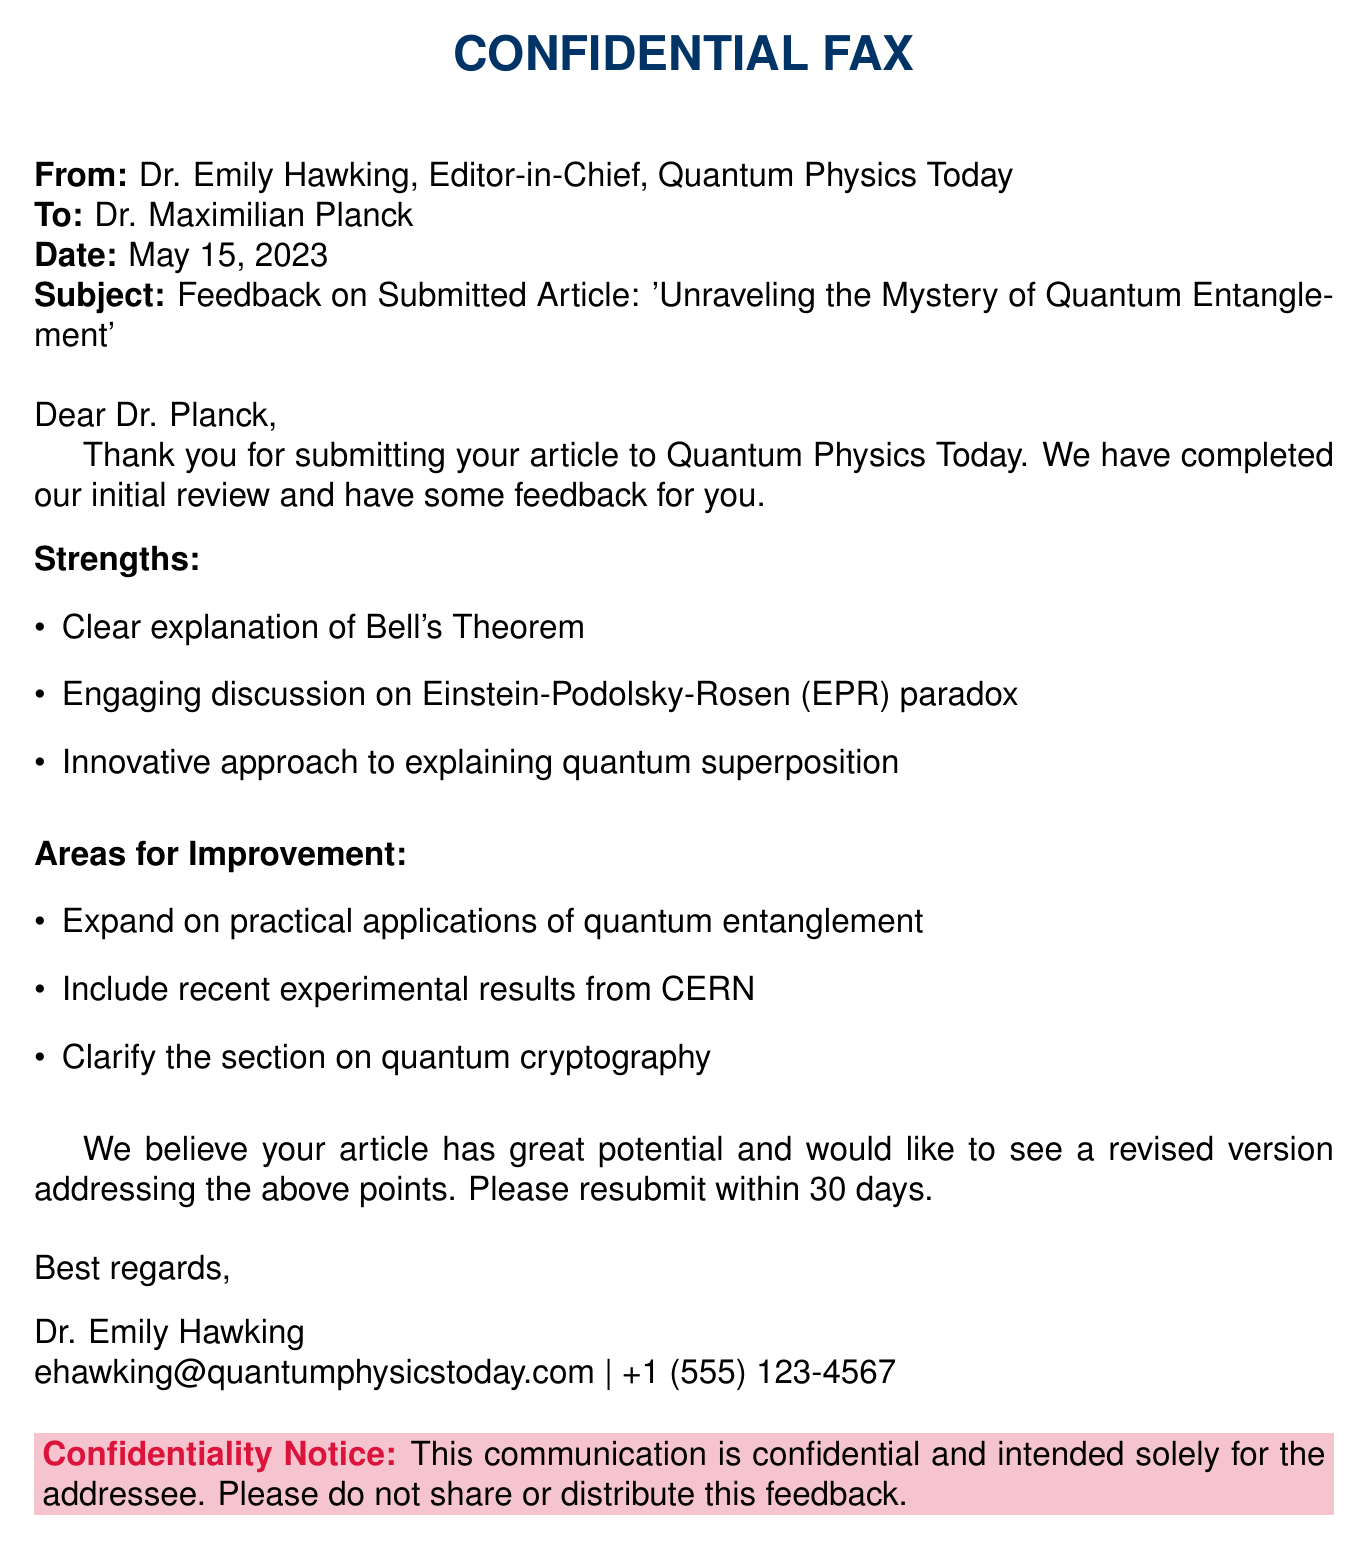What is the name of the journal? The journal's name is located in the header of the document, under the signature, which is Quantum Physics Today.
Answer: Quantum Physics Today Who is the author of the submitted article? The name of the author is mentioned in the 'To' section of the fax, which is Dr. Maximilian Planck.
Answer: Dr. Maximilian Planck What is the date of the fax? The date is specified in the 'Date' line of the document, which is May 15, 2023.
Answer: May 15, 2023 What are the strengths of the article? This is found in the 'Strengths' bullet points, which include clear explanation of Bell's Theorem, engaging discussion on EPR paradox, and innovative approach to quantum superposition.
Answer: Clear explanation of Bell's Theorem, engaging discussion on EPR paradox, innovative approach to quantum superposition What are the areas for improvement mentioned? These are listed in the 'Areas for Improvement' section including expand on practical applications, include recent experimental results, and clarify quantum cryptography.
Answer: Expand on practical applications of quantum entanglement, include recent experimental results from CERN, clarify the section on quantum cryptography What should the author do after receiving this feedback? This is indicated in the conclusion of the document, where it requests a revised version addressing the feedback.
Answer: Resubmit within 30 days What is the role of Dr. Emily Hawking? The role is specified in the 'From' line of the fax, as Editor-in-Chief.
Answer: Editor-in-Chief What is the confidentiality notice about? This is found in the confidentiality box at the bottom, stating that the communication is confidential and intended solely for the addressee.
Answer: Confidential and intended solely for the addressee 